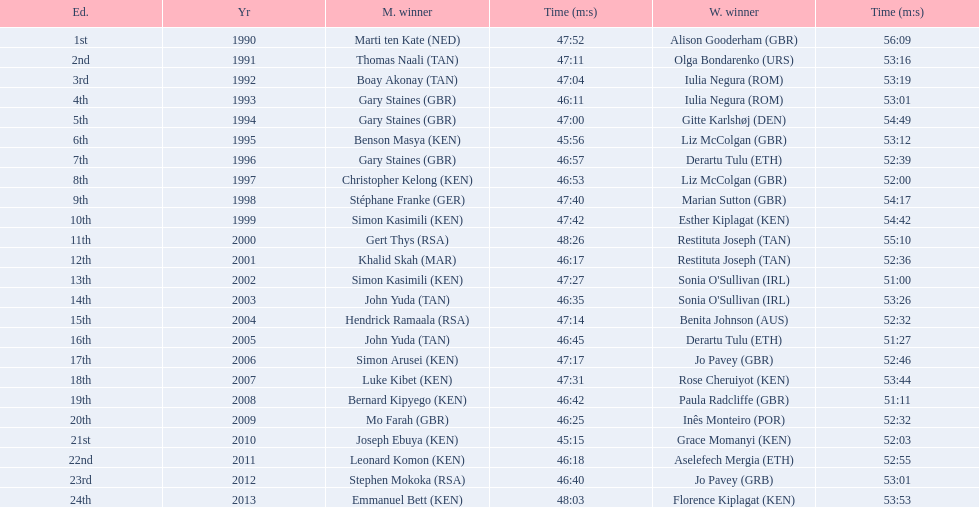Which runners are from kenya? (ken) Benson Masya (KEN), Christopher Kelong (KEN), Simon Kasimili (KEN), Simon Kasimili (KEN), Simon Arusei (KEN), Luke Kibet (KEN), Bernard Kipyego (KEN), Joseph Ebuya (KEN), Leonard Komon (KEN), Emmanuel Bett (KEN). Of these, which times are under 46 minutes? Benson Masya (KEN), Joseph Ebuya (KEN). Which of these runners had the faster time? Joseph Ebuya (KEN). 